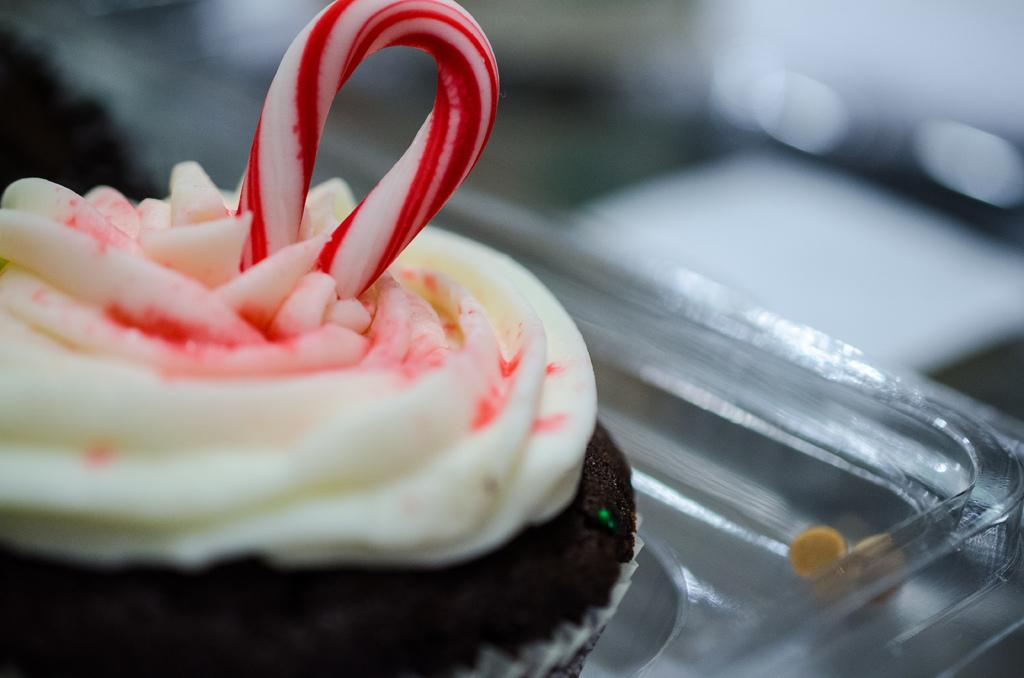What type of dessert is featured in the image? There is a chocolate cupcake in the image. How is the cupcake positioned in the image? The cupcake is placed on a glass tray. What color is the background of the image? The background of the image is white in color. How is the focus of the image? The image is blurred in the background. What type of border is present around the cupcake in the image? There is no border present around the cupcake in the image. What board is visible in the image? There is no board present in the image. 